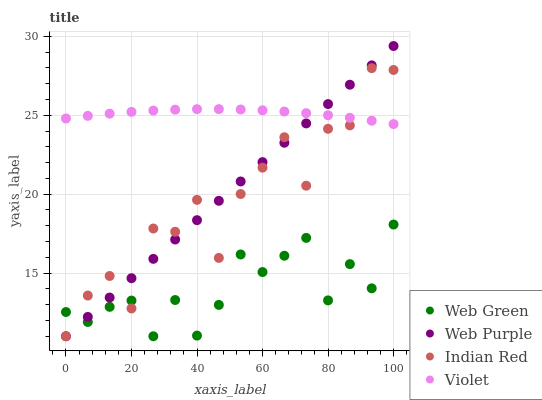Does Web Green have the minimum area under the curve?
Answer yes or no. Yes. Does Violet have the maximum area under the curve?
Answer yes or no. Yes. Does Indian Red have the minimum area under the curve?
Answer yes or no. No. Does Indian Red have the maximum area under the curve?
Answer yes or no. No. Is Web Purple the smoothest?
Answer yes or no. Yes. Is Indian Red the roughest?
Answer yes or no. Yes. Is Web Green the smoothest?
Answer yes or no. No. Is Web Green the roughest?
Answer yes or no. No. Does Web Purple have the lowest value?
Answer yes or no. Yes. Does Violet have the lowest value?
Answer yes or no. No. Does Web Purple have the highest value?
Answer yes or no. Yes. Does Indian Red have the highest value?
Answer yes or no. No. Is Web Green less than Violet?
Answer yes or no. Yes. Is Violet greater than Web Green?
Answer yes or no. Yes. Does Web Green intersect Web Purple?
Answer yes or no. Yes. Is Web Green less than Web Purple?
Answer yes or no. No. Is Web Green greater than Web Purple?
Answer yes or no. No. Does Web Green intersect Violet?
Answer yes or no. No. 